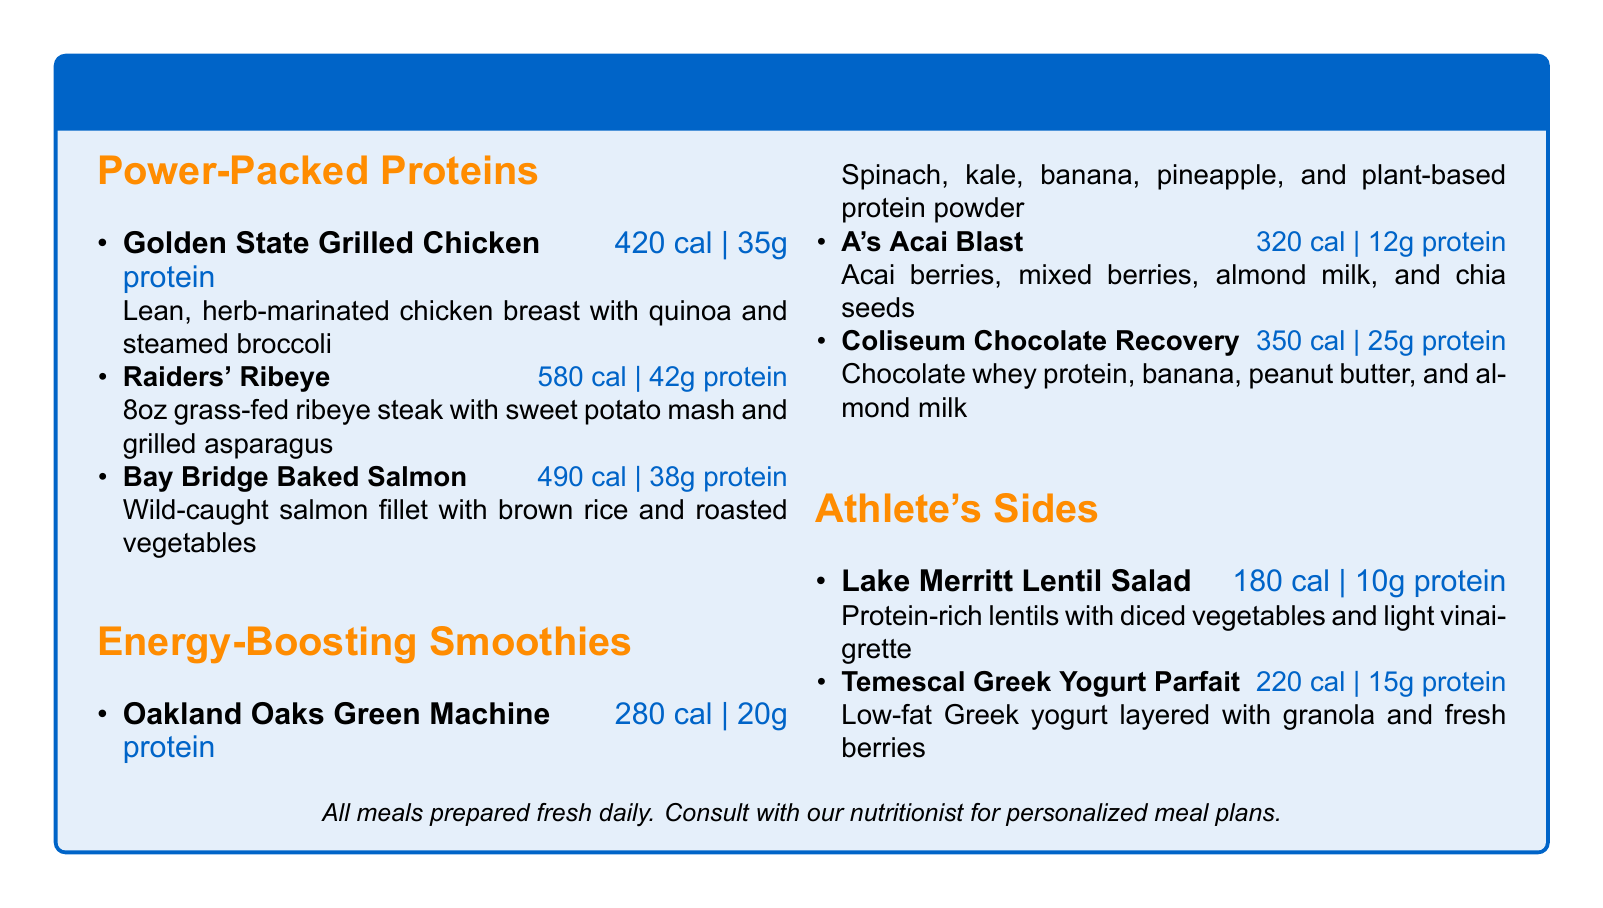What is the calorie count of the Golden State Grilled Chicken? The calorie count is specified under the dish, which is 420 calories.
Answer: 420 How much protein is in the Raiders' Ribeye? The protein amount is listed alongside the dish, which is 42 grams.
Answer: 42g What are the ingredients in the Oakland Oaks Green Machine? The ingredients are provided in the description of the smoothie, which includes spinach, kale, banana, pineapple, and plant-based protein powder.
Answer: Spinach, kale, banana, pineapple, plant-based protein powder Which dish has the highest calorie count? The calorie counts are compared, with the Raiders' Ribeye at 580 calories being the highest.
Answer: Raiders' Ribeye How many grams of protein does the A's Acai Blast contain? The protein amount is stated next to the smoothie, that it contains 12 grams.
Answer: 12g How many sides are listed in the menu? The menu contains three sides under the "Athlete's Sides" section.
Answer: 2 What is the total protein provided by the Coliseum Chocolate Recovery? The protein amount is given with the smoothie details, which is 25 grams.
Answer: 25g What type of yogurt is used in the Temescal Greek Yogurt Parfait? The yogurt type is mentioned in the dish description, which is low-fat Greek yogurt.
Answer: Low-fat Greek yogurt 